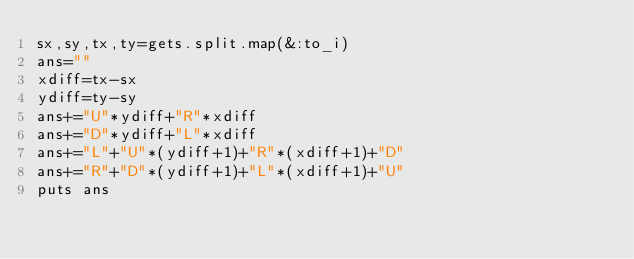Convert code to text. <code><loc_0><loc_0><loc_500><loc_500><_Ruby_>sx,sy,tx,ty=gets.split.map(&:to_i)
ans=""
xdiff=tx-sx
ydiff=ty-sy
ans+="U"*ydiff+"R"*xdiff
ans+="D"*ydiff+"L"*xdiff
ans+="L"+"U"*(ydiff+1)+"R"*(xdiff+1)+"D"
ans+="R"+"D"*(ydiff+1)+"L"*(xdiff+1)+"U"
puts ans
</code> 